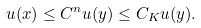Convert formula to latex. <formula><loc_0><loc_0><loc_500><loc_500>u ( x ) \leq C ^ { n } u ( y ) \leq C _ { K } u ( y ) .</formula> 